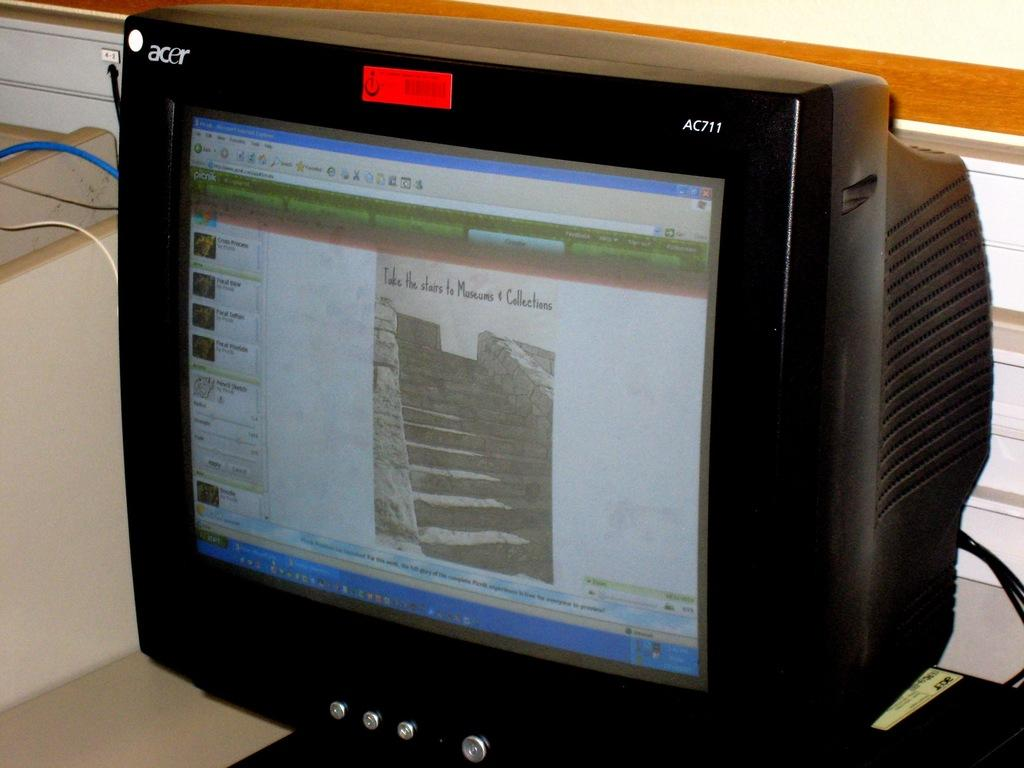<image>
Describe the image concisely. The black computer shown is made by Acer. 